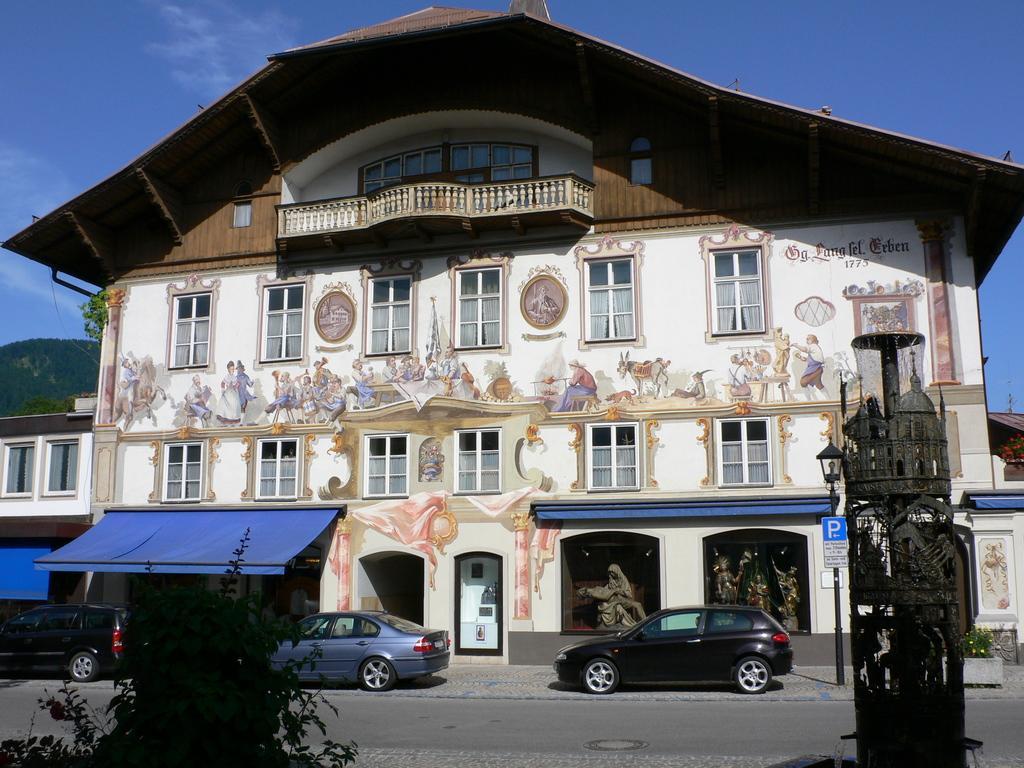Could you give a brief overview of what you see in this image? In this picture we can see plant, water fountain and cars on the road. We can see building, board on pole, painting on the wall, windows and statues. In the background of the image we can see roof top, hill, flowers and sky. 